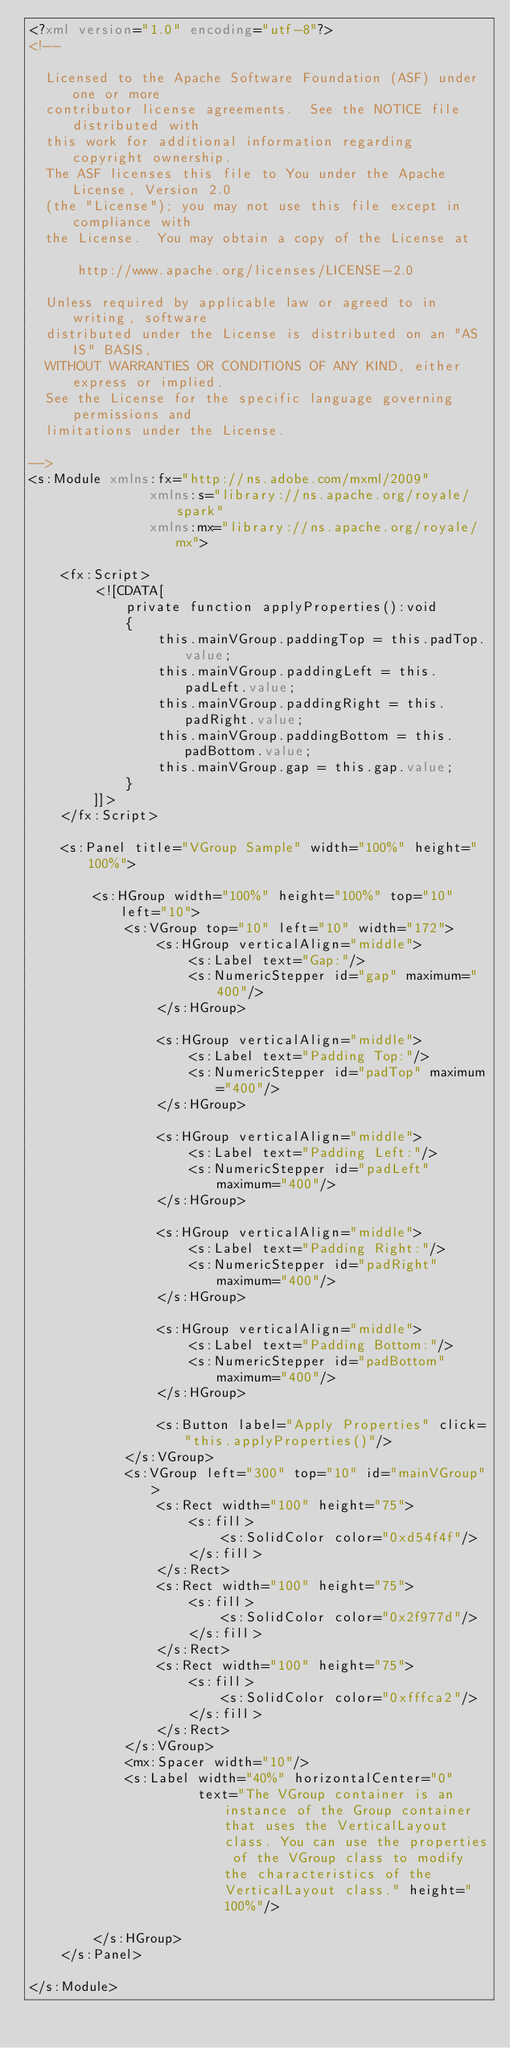<code> <loc_0><loc_0><loc_500><loc_500><_XML_><?xml version="1.0" encoding="utf-8"?>
<!--

  Licensed to the Apache Software Foundation (ASF) under one or more
  contributor license agreements.  See the NOTICE file distributed with
  this work for additional information regarding copyright ownership.
  The ASF licenses this file to You under the Apache License, Version 2.0
  (the "License"); you may not use this file except in compliance with
  the License.  You may obtain a copy of the License at

      http://www.apache.org/licenses/LICENSE-2.0

  Unless required by applicable law or agreed to in writing, software
  distributed under the License is distributed on an "AS IS" BASIS,
  WITHOUT WARRANTIES OR CONDITIONS OF ANY KIND, either express or implied.
  See the License for the specific language governing permissions and
  limitations under the License.

-->
<s:Module xmlns:fx="http://ns.adobe.com/mxml/2009" 
			   xmlns:s="library://ns.apache.org/royale/spark" 
			   xmlns:mx="library://ns.apache.org/royale/mx">

	<fx:Script>
		<![CDATA[
			private function applyProperties():void
			{
				this.mainVGroup.paddingTop = this.padTop.value;
				this.mainVGroup.paddingLeft = this.padLeft.value;
				this.mainVGroup.paddingRight = this.padRight.value;
				this.mainVGroup.paddingBottom = this.padBottom.value;
				this.mainVGroup.gap = this.gap.value;
			}
		]]>
	</fx:Script>
	
	<s:Panel title="VGroup Sample" width="100%" height="100%">
		
		<s:HGroup width="100%" height="100%" top="10" left="10">
			<s:VGroup top="10" left="10" width="172">
				<s:HGroup verticalAlign="middle">
					<s:Label text="Gap:"/>
					<s:NumericStepper id="gap" maximum="400"/>
				</s:HGroup>	
				
				<s:HGroup verticalAlign="middle">
					<s:Label text="Padding Top:"/>
					<s:NumericStepper id="padTop" maximum="400"/>
				</s:HGroup>
				
				<s:HGroup verticalAlign="middle">
					<s:Label text="Padding Left:"/>
					<s:NumericStepper id="padLeft" maximum="400"/>
				</s:HGroup>
				
				<s:HGroup verticalAlign="middle">
					<s:Label text="Padding Right:"/>
					<s:NumericStepper id="padRight" maximum="400"/>
				</s:HGroup>
				
				<s:HGroup verticalAlign="middle">
					<s:Label text="Padding Bottom:"/>
					<s:NumericStepper id="padBottom" maximum="400"/>
				</s:HGroup>	
				
				<s:Button label="Apply Properties" click="this.applyProperties()"/>
			</s:VGroup>
			<s:VGroup left="300" top="10" id="mainVGroup">
				<s:Rect width="100" height="75">
					<s:fill>
						<s:SolidColor color="0xd54f4f"/>
					</s:fill>
				</s:Rect>
				<s:Rect width="100" height="75">
					<s:fill>
						<s:SolidColor color="0x2f977d"/>
					</s:fill>
				</s:Rect>
				<s:Rect width="100" height="75">
					<s:fill>
						<s:SolidColor color="0xfffca2"/>
					</s:fill>
				</s:Rect>
			</s:VGroup>	
			<mx:Spacer width="10"/>
			<s:Label width="40%" horizontalCenter="0" 
					 text="The VGroup container is an instance of the Group container that uses the VerticalLayout class. You can use the properties of the VGroup class to modify the characteristics of the VerticalLayout class." height="100%"/>
				
		</s:HGroup>
	</s:Panel>
	
</s:Module>
</code> 